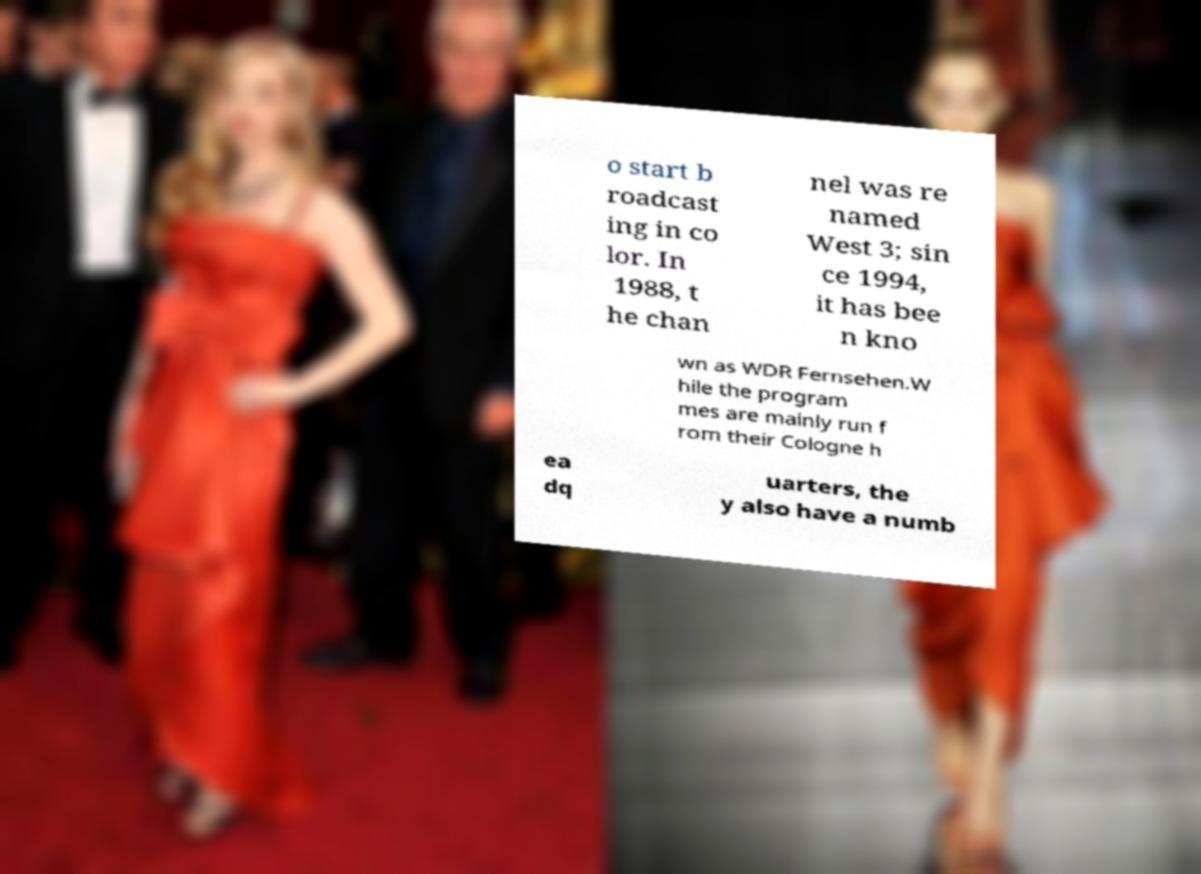What messages or text are displayed in this image? I need them in a readable, typed format. o start b roadcast ing in co lor. In 1988, t he chan nel was re named West 3; sin ce 1994, it has bee n kno wn as WDR Fernsehen.W hile the program mes are mainly run f rom their Cologne h ea dq uarters, the y also have a numb 